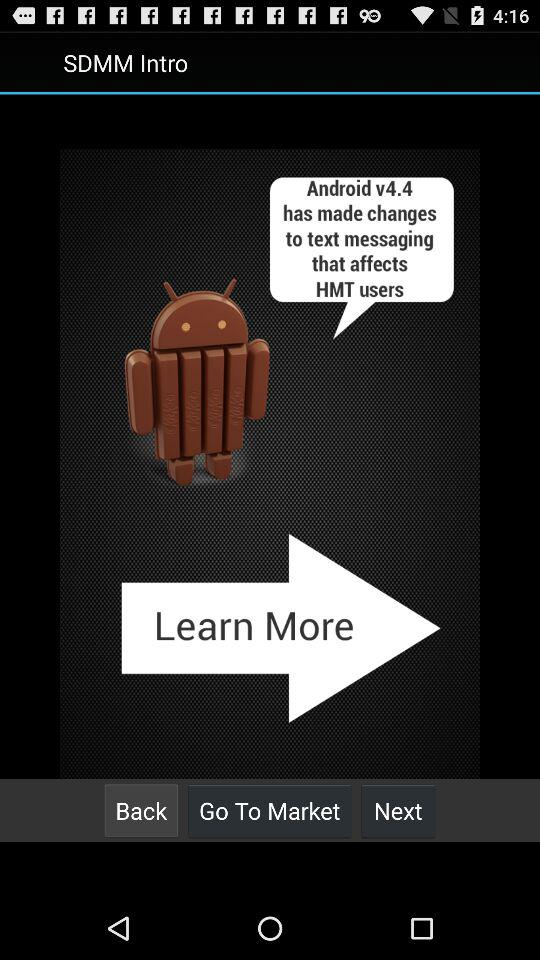Which Android version has made changes to text messaging that affect HTML users? The Android version is v4.4. 